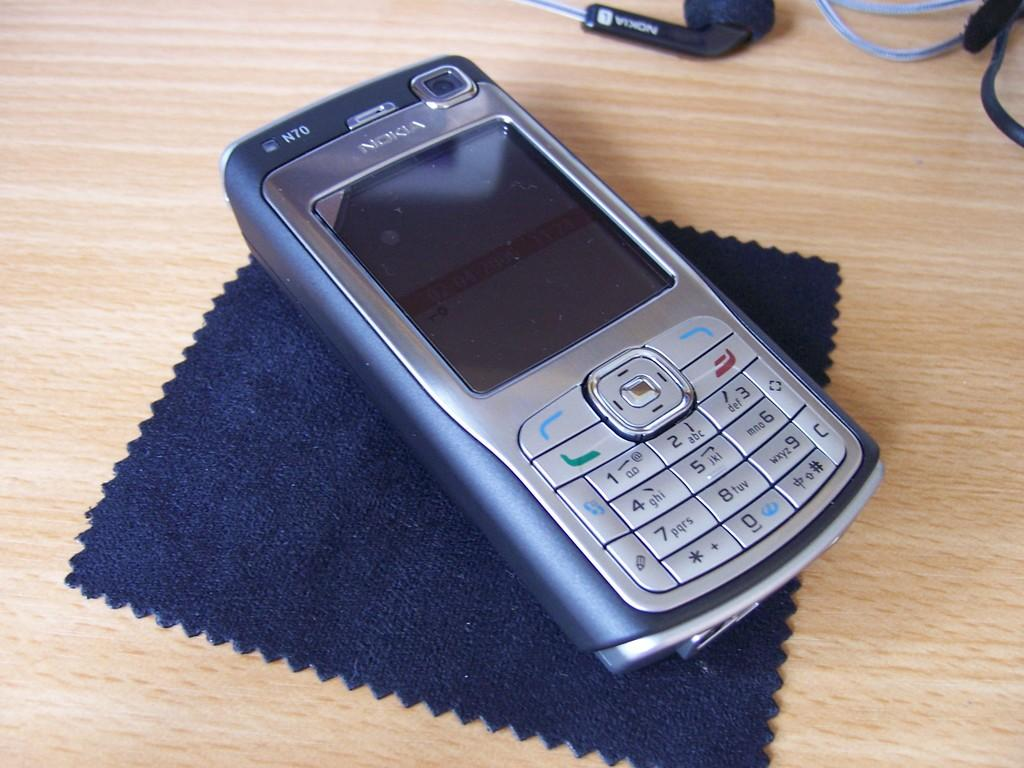<image>
Offer a succinct explanation of the picture presented. A Nokia N70 phone sits on top of a screen-cleaning cloth. 